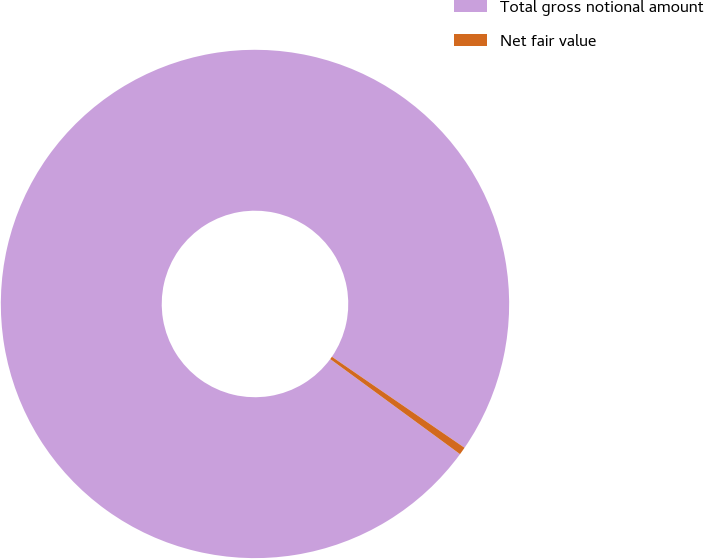Convert chart to OTSL. <chart><loc_0><loc_0><loc_500><loc_500><pie_chart><fcel>Total gross notional amount<fcel>Net fair value<nl><fcel>99.51%<fcel>0.49%<nl></chart> 